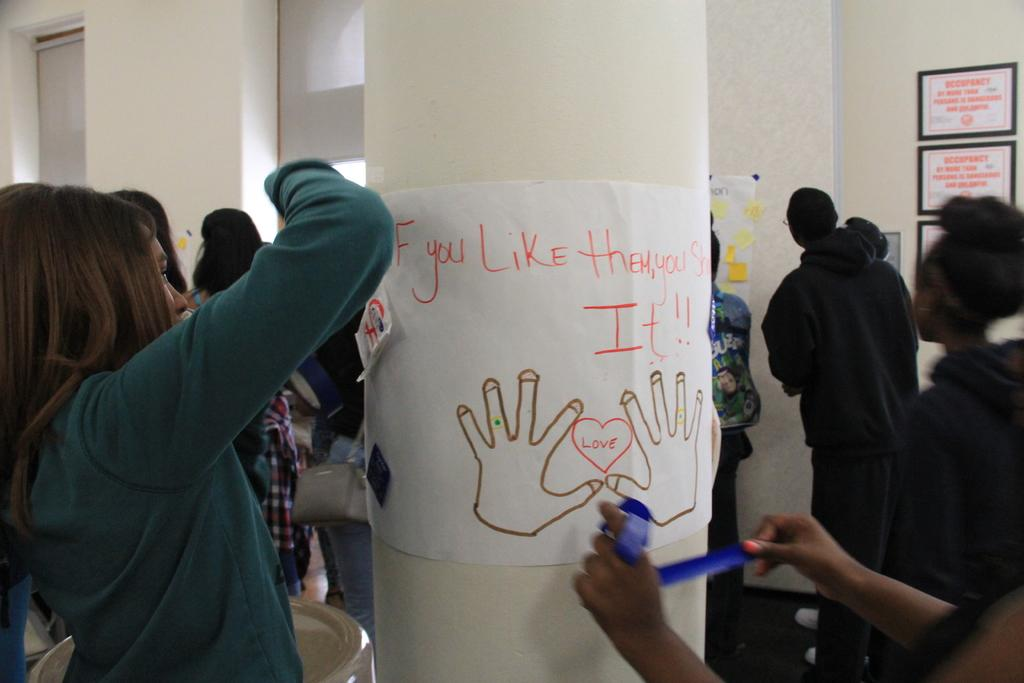What is happening in the image involving a group of people? There is a group of people standing in the image. Can you describe what one person is doing in the image? A person is watching a notice in the image. What object is present in the image that displays notices? There is a notice board displayed in the image. How many ears can be seen on the boys in the image? There is no mention of boys in the image, and therefore no information about their ears. What type of team is visible in the image? There is no team present in the image; it features a group of people and a notice board. 